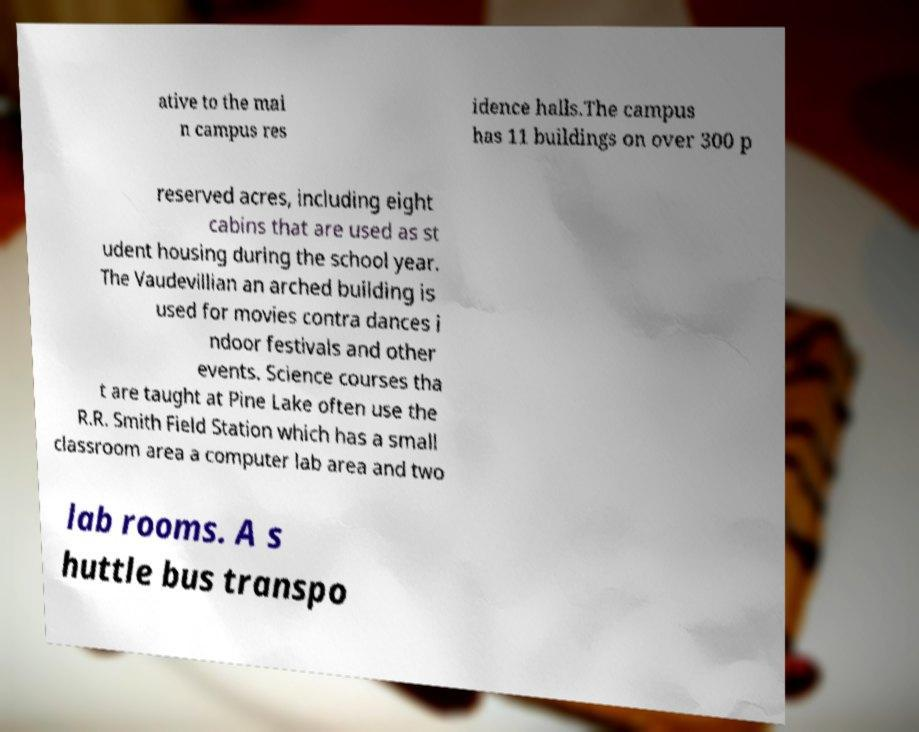Can you read and provide the text displayed in the image?This photo seems to have some interesting text. Can you extract and type it out for me? ative to the mai n campus res idence halls.The campus has 11 buildings on over 300 p reserved acres, including eight cabins that are used as st udent housing during the school year. The Vaudevillian an arched building is used for movies contra dances i ndoor festivals and other events. Science courses tha t are taught at Pine Lake often use the R.R. Smith Field Station which has a small classroom area a computer lab area and two lab rooms. A s huttle bus transpo 